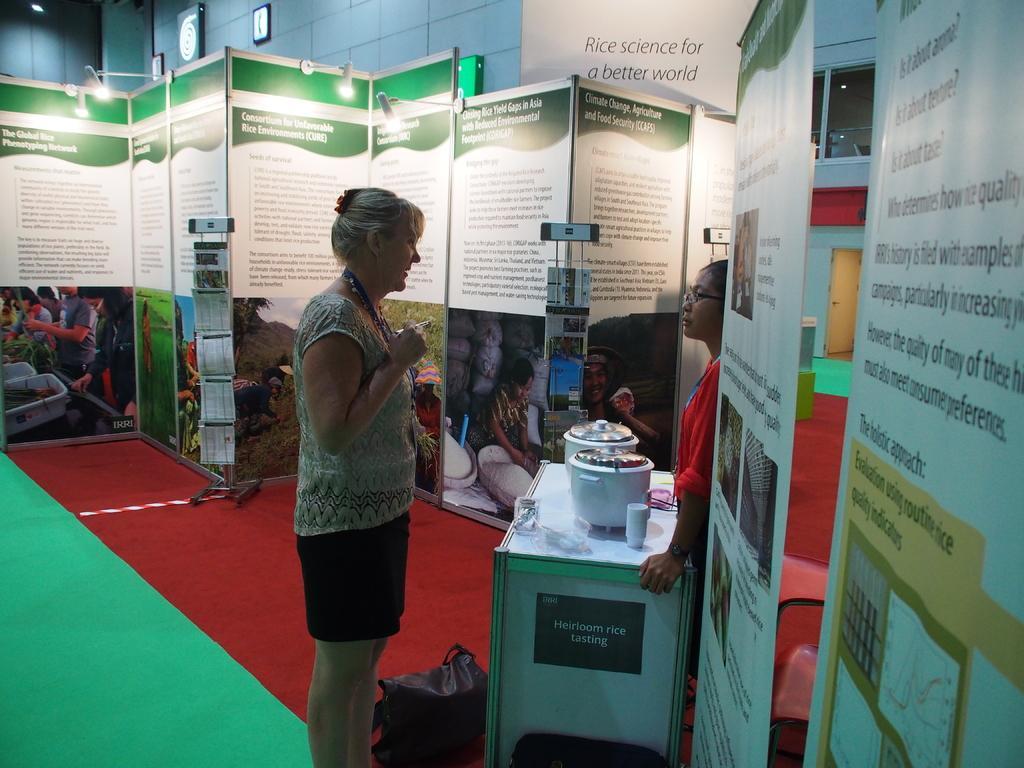In one or two sentences, can you explain what this image depicts? In the center of the image there is a woman standing on the floor. On the right side of the image we can see posters, rice cookers, table and woman. In the background there is a wall, posters and books. 